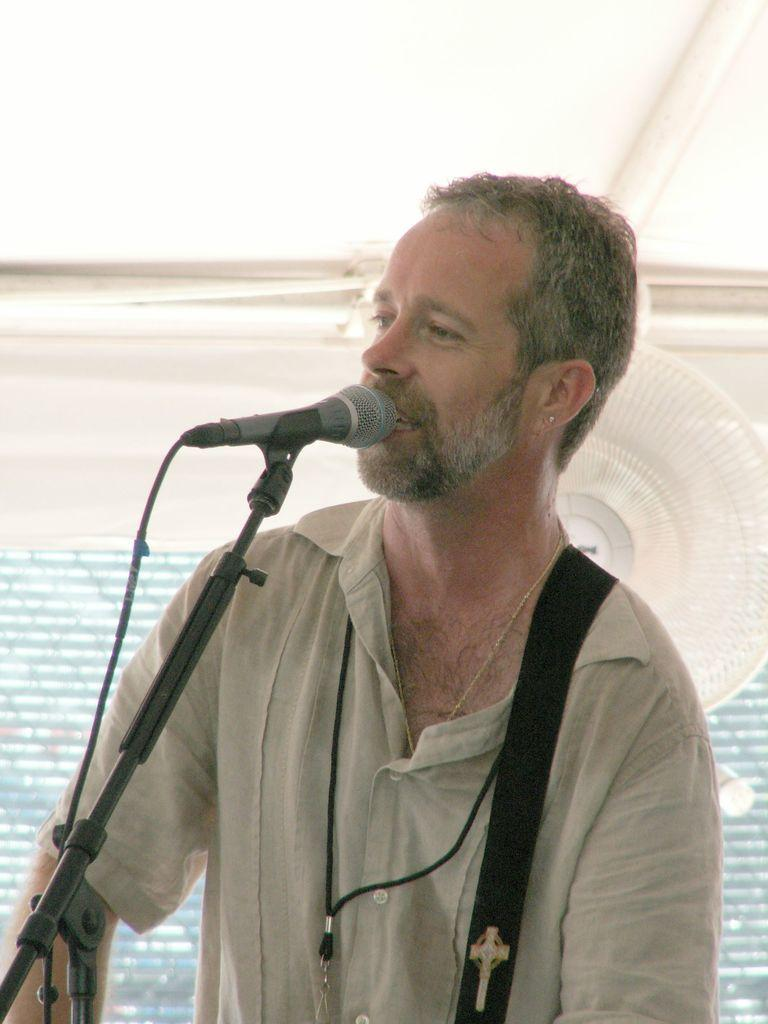Who is the main subject in the image? There is a man in the center of the image. What is the man doing in the image? The man is singing. What tool is the man using while singing? The man is using a microphone. Can you identify any other objects in the image? Yes, there is a table fan in the image. What type of beam is the man using to support the microphone in the image? There is no beam present in the image, and the man is not using any beam to support the microphone. 